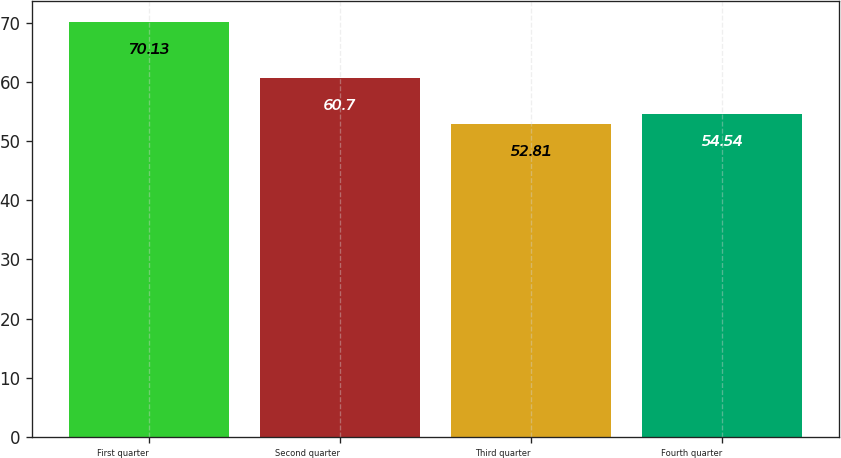Convert chart to OTSL. <chart><loc_0><loc_0><loc_500><loc_500><bar_chart><fcel>First quarter<fcel>Second quarter<fcel>Third quarter<fcel>Fourth quarter<nl><fcel>70.13<fcel>60.7<fcel>52.81<fcel>54.54<nl></chart> 